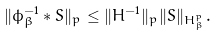Convert formula to latex. <formula><loc_0><loc_0><loc_500><loc_500>\| \phi _ { \beta } ^ { - 1 } \ast S \| _ { p } \leq \| H ^ { - 1 } \| _ { p } \| S \| _ { H ^ { p } _ { \beta } } .</formula> 